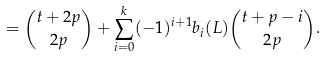Convert formula to latex. <formula><loc_0><loc_0><loc_500><loc_500>= { t + 2 p \choose 2 p } + \sum _ { i = 0 } ^ { k } ( - 1 ) ^ { i + 1 } b _ { i } ( L ) { t + p - i \choose 2 p } .</formula> 